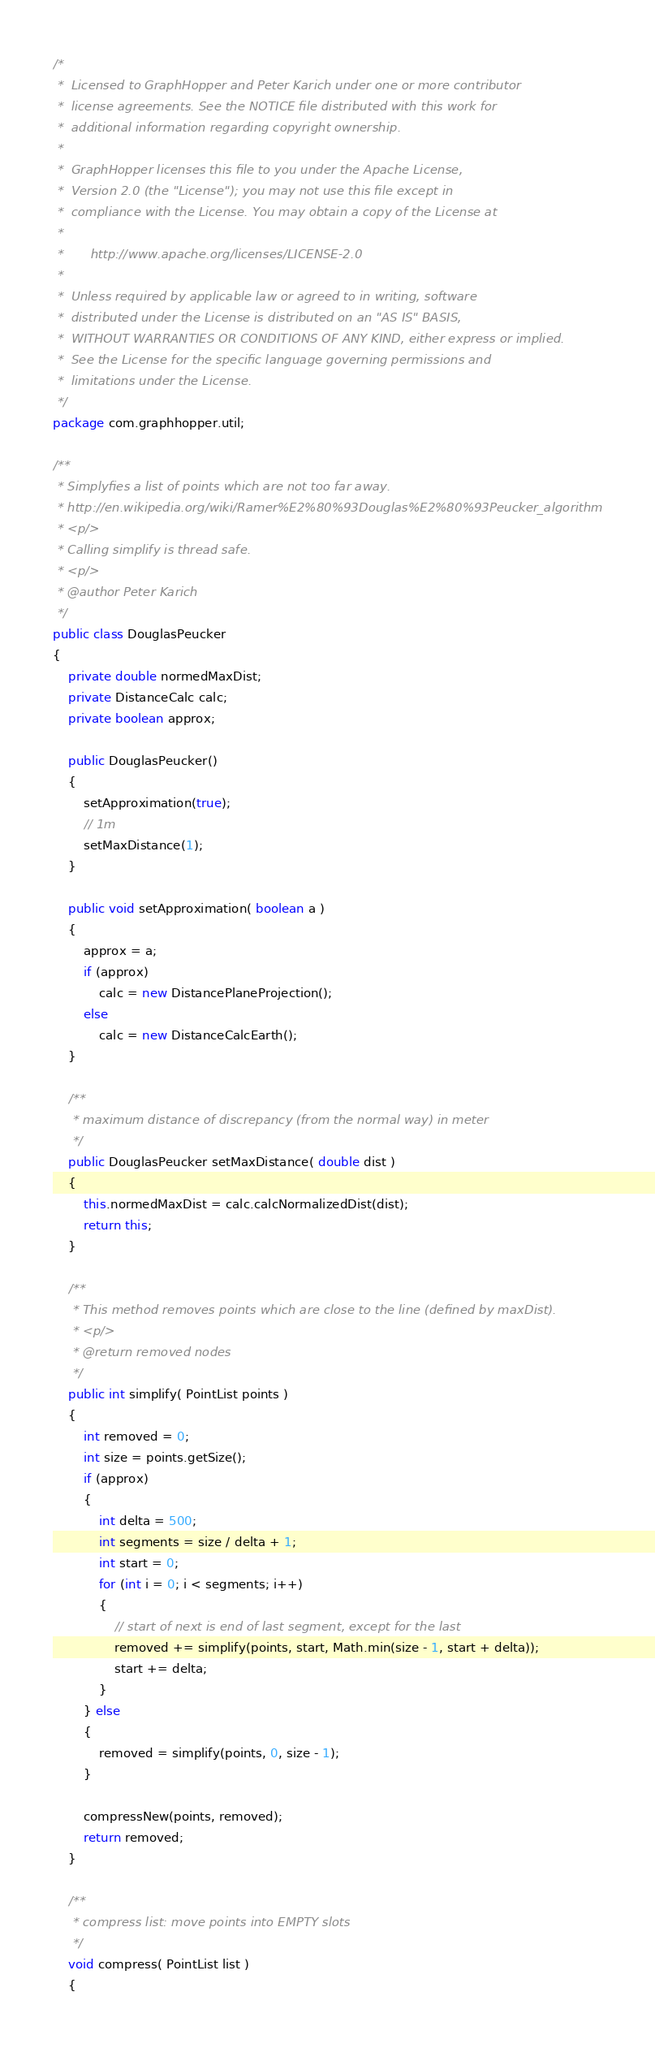<code> <loc_0><loc_0><loc_500><loc_500><_Java_>/*
 *  Licensed to GraphHopper and Peter Karich under one or more contributor
 *  license agreements. See the NOTICE file distributed with this work for 
 *  additional information regarding copyright ownership.
 * 
 *  GraphHopper licenses this file to you under the Apache License, 
 *  Version 2.0 (the "License"); you may not use this file except in 
 *  compliance with the License. You may obtain a copy of the License at
 * 
 *       http://www.apache.org/licenses/LICENSE-2.0
 * 
 *  Unless required by applicable law or agreed to in writing, software
 *  distributed under the License is distributed on an "AS IS" BASIS,
 *  WITHOUT WARRANTIES OR CONDITIONS OF ANY KIND, either express or implied.
 *  See the License for the specific language governing permissions and
 *  limitations under the License.
 */
package com.graphhopper.util;

/**
 * Simplyfies a list of points which are not too far away.
 * http://en.wikipedia.org/wiki/Ramer%E2%80%93Douglas%E2%80%93Peucker_algorithm
 * <p/>
 * Calling simplify is thread safe.
 * <p/>
 * @author Peter Karich
 */
public class DouglasPeucker
{
    private double normedMaxDist;
    private DistanceCalc calc;
    private boolean approx;

    public DouglasPeucker()
    {
        setApproximation(true);
        // 1m
        setMaxDistance(1);
    }

    public void setApproximation( boolean a )
    {
        approx = a;
        if (approx)
            calc = new DistancePlaneProjection();
        else
            calc = new DistanceCalcEarth();
    }

    /**
     * maximum distance of discrepancy (from the normal way) in meter
     */
    public DouglasPeucker setMaxDistance( double dist )
    {
        this.normedMaxDist = calc.calcNormalizedDist(dist);
        return this;
    }

    /**
     * This method removes points which are close to the line (defined by maxDist).
     * <p/>
     * @return removed nodes
     */
    public int simplify( PointList points )
    {
        int removed = 0;
        int size = points.getSize();
        if (approx)
        {
            int delta = 500;
            int segments = size / delta + 1;
            int start = 0;
            for (int i = 0; i < segments; i++)
            {
                // start of next is end of last segment, except for the last
                removed += simplify(points, start, Math.min(size - 1, start + delta));
                start += delta;
            }
        } else
        {
            removed = simplify(points, 0, size - 1);
        }

        compressNew(points, removed);
        return removed;
    }

    /**
     * compress list: move points into EMPTY slots
     */
    void compress( PointList list )
    {</code> 